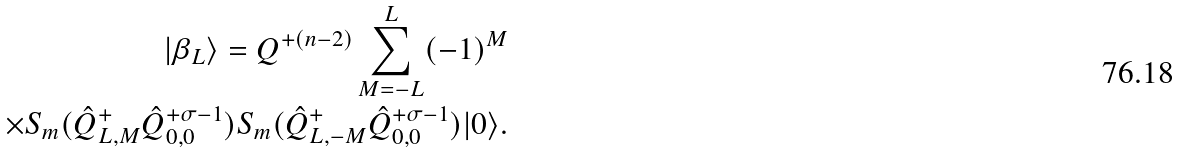<formula> <loc_0><loc_0><loc_500><loc_500>| \beta _ { L } \rangle = Q ^ { + ( n - 2 ) } \sum _ { M = - L } ^ { L } ( - 1 ) ^ { M } \\ \times S _ { m } ( \hat { Q } ^ { + } _ { L , M } \hat { Q } ^ { + \sigma - 1 } _ { 0 , 0 } ) S _ { m } ( \hat { Q } ^ { + } _ { L , - M } \hat { Q } ^ { + \sigma - 1 } _ { 0 , 0 } ) | 0 \rangle .</formula> 